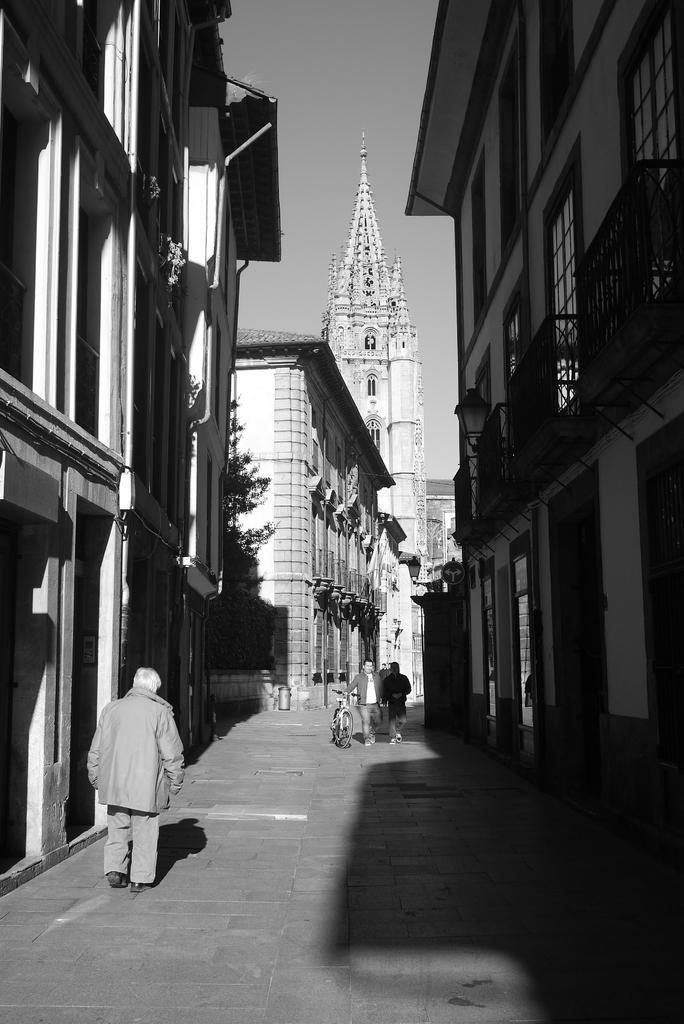Please provide a concise description of this image. In this image I can see a street in which I can see a person walking, two other persons standing and one of them is holding a bicycle. I can see few buildings on both sides of the street. In the background I can see a tree and the sky. 